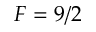Convert formula to latex. <formula><loc_0><loc_0><loc_500><loc_500>F = 9 / 2</formula> 